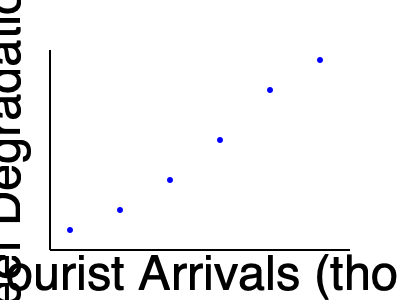Based on the scatter plot showing the relationship between annual tourist arrivals and coral reef degradation in the Cook Islands, what can be inferred about the impact of tourism on the local marine environment? How might this trend affect the sustainability of Cook Islands' tourism industry in the long term? To answer this question, let's analyze the scatter plot step-by-step:

1. Observe the axes:
   - X-axis represents Annual Tourist Arrivals (in thousands)
   - Y-axis represents Coral Reef Degradation Index

2. Analyze the trend:
   - As we move from left to right (increasing tourist arrivals), the points move upwards (increasing coral reef degradation)
   - This indicates a positive correlation between tourist arrivals and coral reef degradation

3. Interpret the relationship:
   - More tourists seem to be associated with higher levels of coral reef degradation
   - This suggests that tourism may be having a negative impact on the marine environment

4. Consider the implications:
   - Coral reefs are crucial for marine biodiversity and are a major attraction for tourists
   - Continued degradation could lead to a decline in the quality of the marine environment

5. Long-term sustainability:
   - If this trend continues, it could threaten the very ecosystem that attracts tourists
   - This may lead to a decline in tourism in the future, as the coral reefs become less attractive or even disappear

6. Potential solutions:
   - Implementing sustainable tourism practices
   - Limiting the number of visitors or restricting access to sensitive areas
   - Educating tourists about responsible behavior in marine environments

In conclusion, the data suggests that increasing tourism is correlated with coral reef degradation in the Cook Islands. This trend poses a significant threat to the long-term sustainability of the tourism industry, as it may eventually destroy the natural attractions that draw visitors to the islands.
Answer: Positive correlation between tourism and coral reef degradation, threatening long-term sustainability of Cook Islands' tourism industry. 